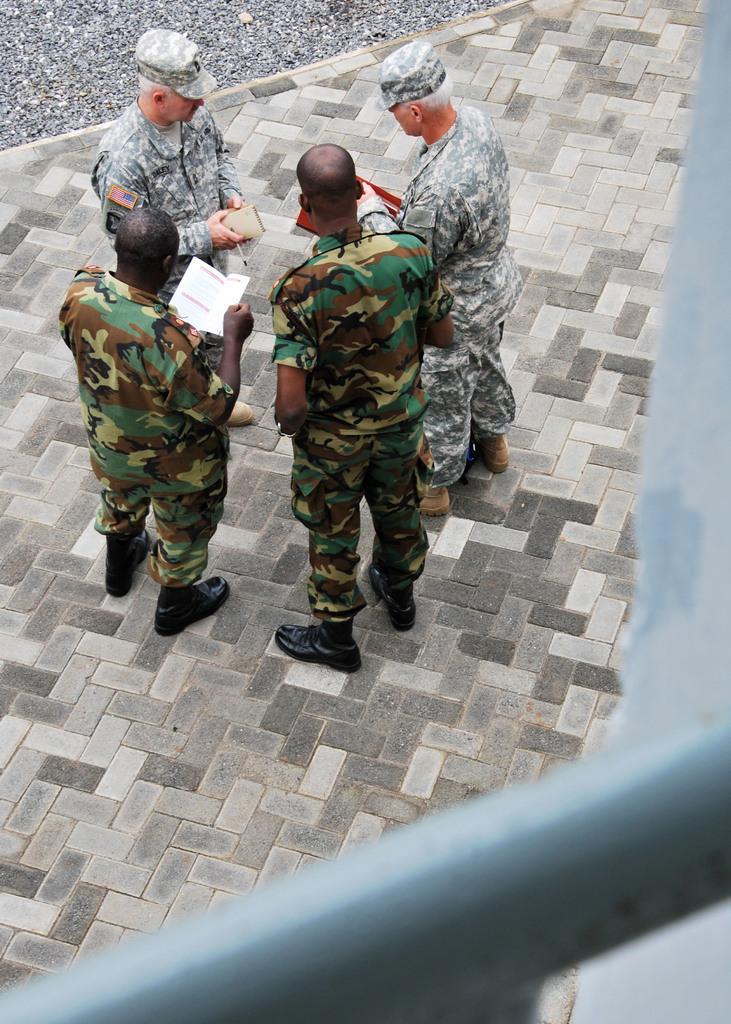In one or two sentences, can you explain what this image depicts? In this image I can see there are four persons standing on the floor and there are holding the papers and pens and two of them are wearing caps and at the bottom I can see rod 